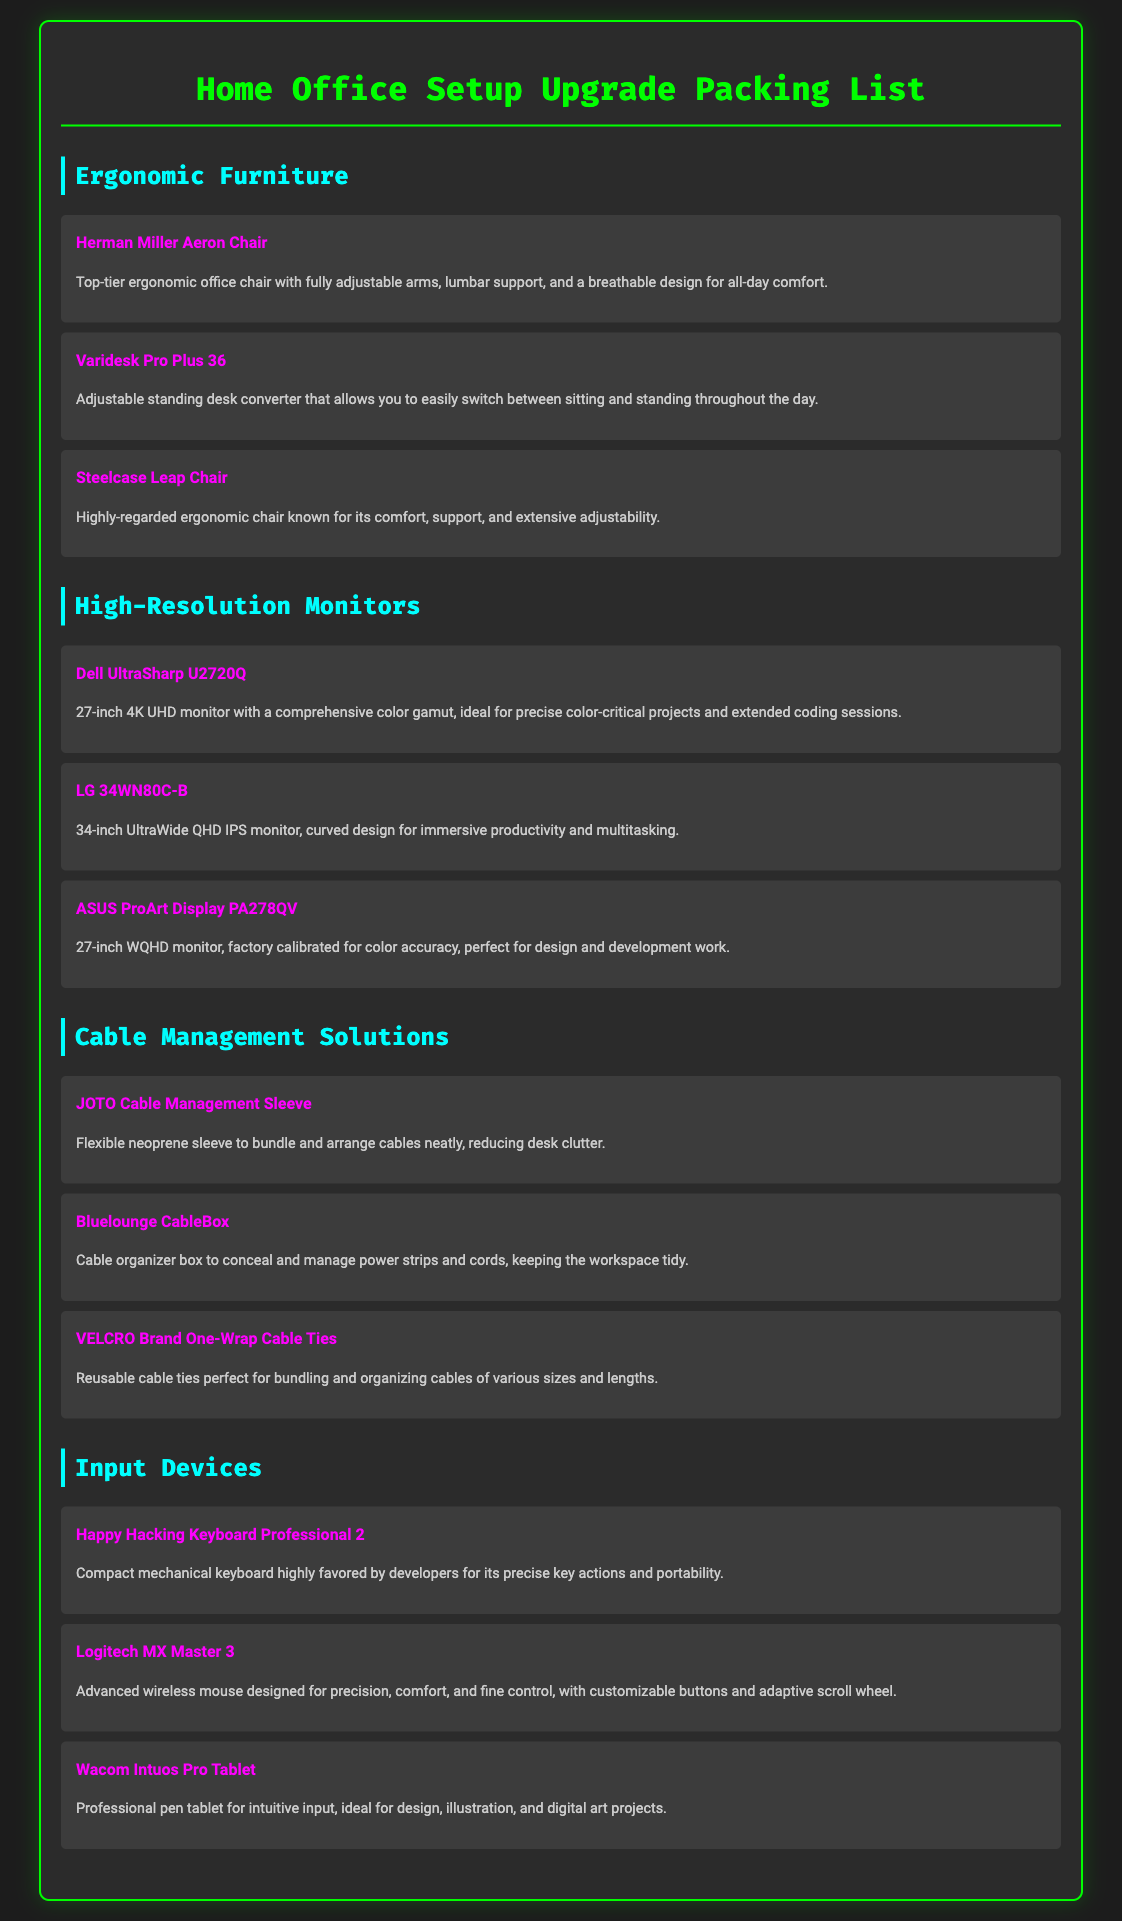what is the name of the ergonomic chair with lumbar support? The ergonomic chair with lumbar support mentioned in the document is the "Herman Miller Aeron Chair."
Answer: Herman Miller Aeron Chair how many high-resolution monitors are listed? There are three high-resolution monitors listed under the High-Resolution Monitors category of the document.
Answer: 3 what is the item name for the input device known for being compact and favored by developers? The compact input device favored by developers is the "Happy Hacking Keyboard Professional 2."
Answer: Happy Hacking Keyboard Professional 2 what is the purpose of the JOTO Cable Management Sleeve? The JOTO Cable Management Sleeve is intended to bundle and arrange cables neatly, reducing desk clutter.
Answer: To bundle and arrange cables which high-resolution monitor is factory calibrated for color accuracy? The monitor that is factory calibrated for color accuracy is the "ASUS ProArt Display PA278QV."
Answer: ASUS ProArt Display PA278QV what is the adjustable desk converter mentioned in the document? The adjustable desk converter mentioned is the "Varidesk Pro Plus 36."
Answer: Varidesk Pro Plus 36 how many input devices are included in the packing list? The packing list includes three input devices listed under the Input Devices category.
Answer: 3 what type of item is the Bluelounge CableBox? The Bluelounge CableBox is a cable organizer box.
Answer: Cable organizer box 